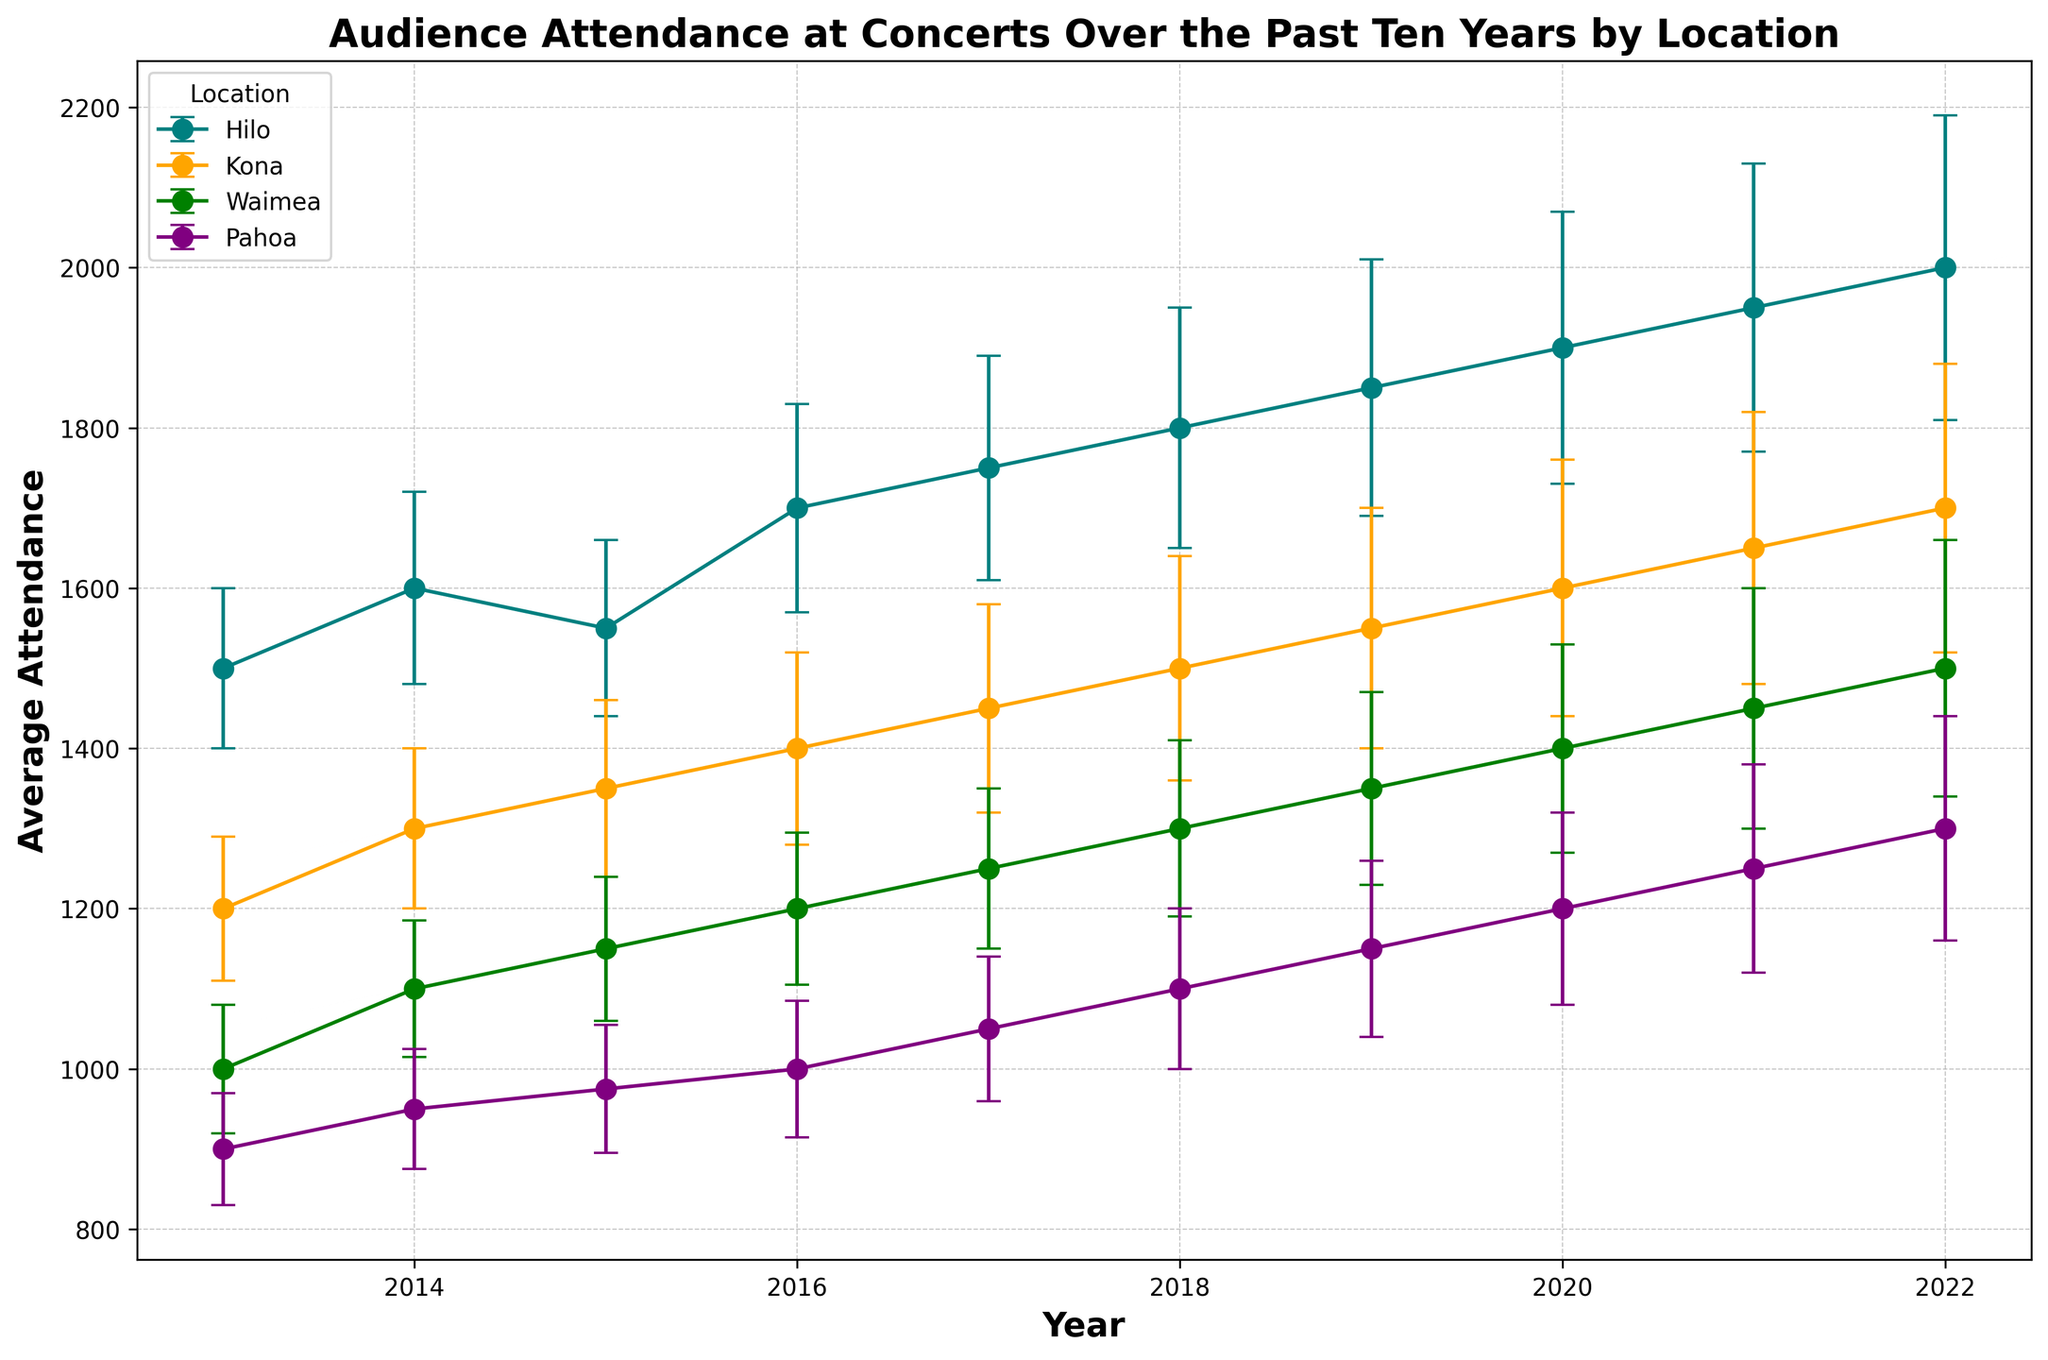What is the general trend in audience attendance in Hilo from 2013 to 2022? The figure shows a consistent upward trend in average attendance in Hilo, starting from 1500 in 2013 and increasing to 2000 in 2022 despite yearly fluctuations.
Answer: Upward trend Which location had the highest average attendance in 2022? In 2022, Hilo had the highest average attendance, with approximately 2000 attendees. This can be seen by comparing the end points of the lines representing different locations.
Answer: Hilo Between Hilo and Kona, which location had a larger increase in attendance from 2013 to 2022? Hilo started at 1500 in 2013 and reached 2000 in 2022, an increase of 500. Kona started at 1200 in 2013 and reached 1700 in 2022, an increase of 500. Despite similar increases, the relative increase is larger in Kona.
Answer: Both had a 500 increase How does Pahoa's attendance growth compare to Waimea's from 2013 to 2022? Pahoa started at 900 and reached 1300, an increase of 400. Waimea started at 1000 and reached 1500, an increase of 500. Waimea had a larger increase in attendance over this period.
Answer: Waimea had a larger increase Which location experienced the least error margin in 2017? In 2017, the visual attributes show that Pahoa, with a thinner error bar around its data point, experienced the least error margin.
Answer: Pahoa What is the average attendance growth rate per year in Waimea from 2013 to 2022? Waimea's attendance increased from 1000 in 2013 to 1500 in 2022. The total growth is 500 over 10 years, so the average yearly growth rate is 500 / 10 = 50 attendees per year.
Answer: 50 attendees per year In what year did Kona surpass 1500 average attendance for the first time? Examining the figure, Kona first surpassed 1500 average attendance in 2018.
Answer: 2018 What was the exact average attendance in Hilo in 2020? By looking closely at the figure, it can be seen that in 2020, Hilo had an average attendance of 1900.
Answer: 1900 